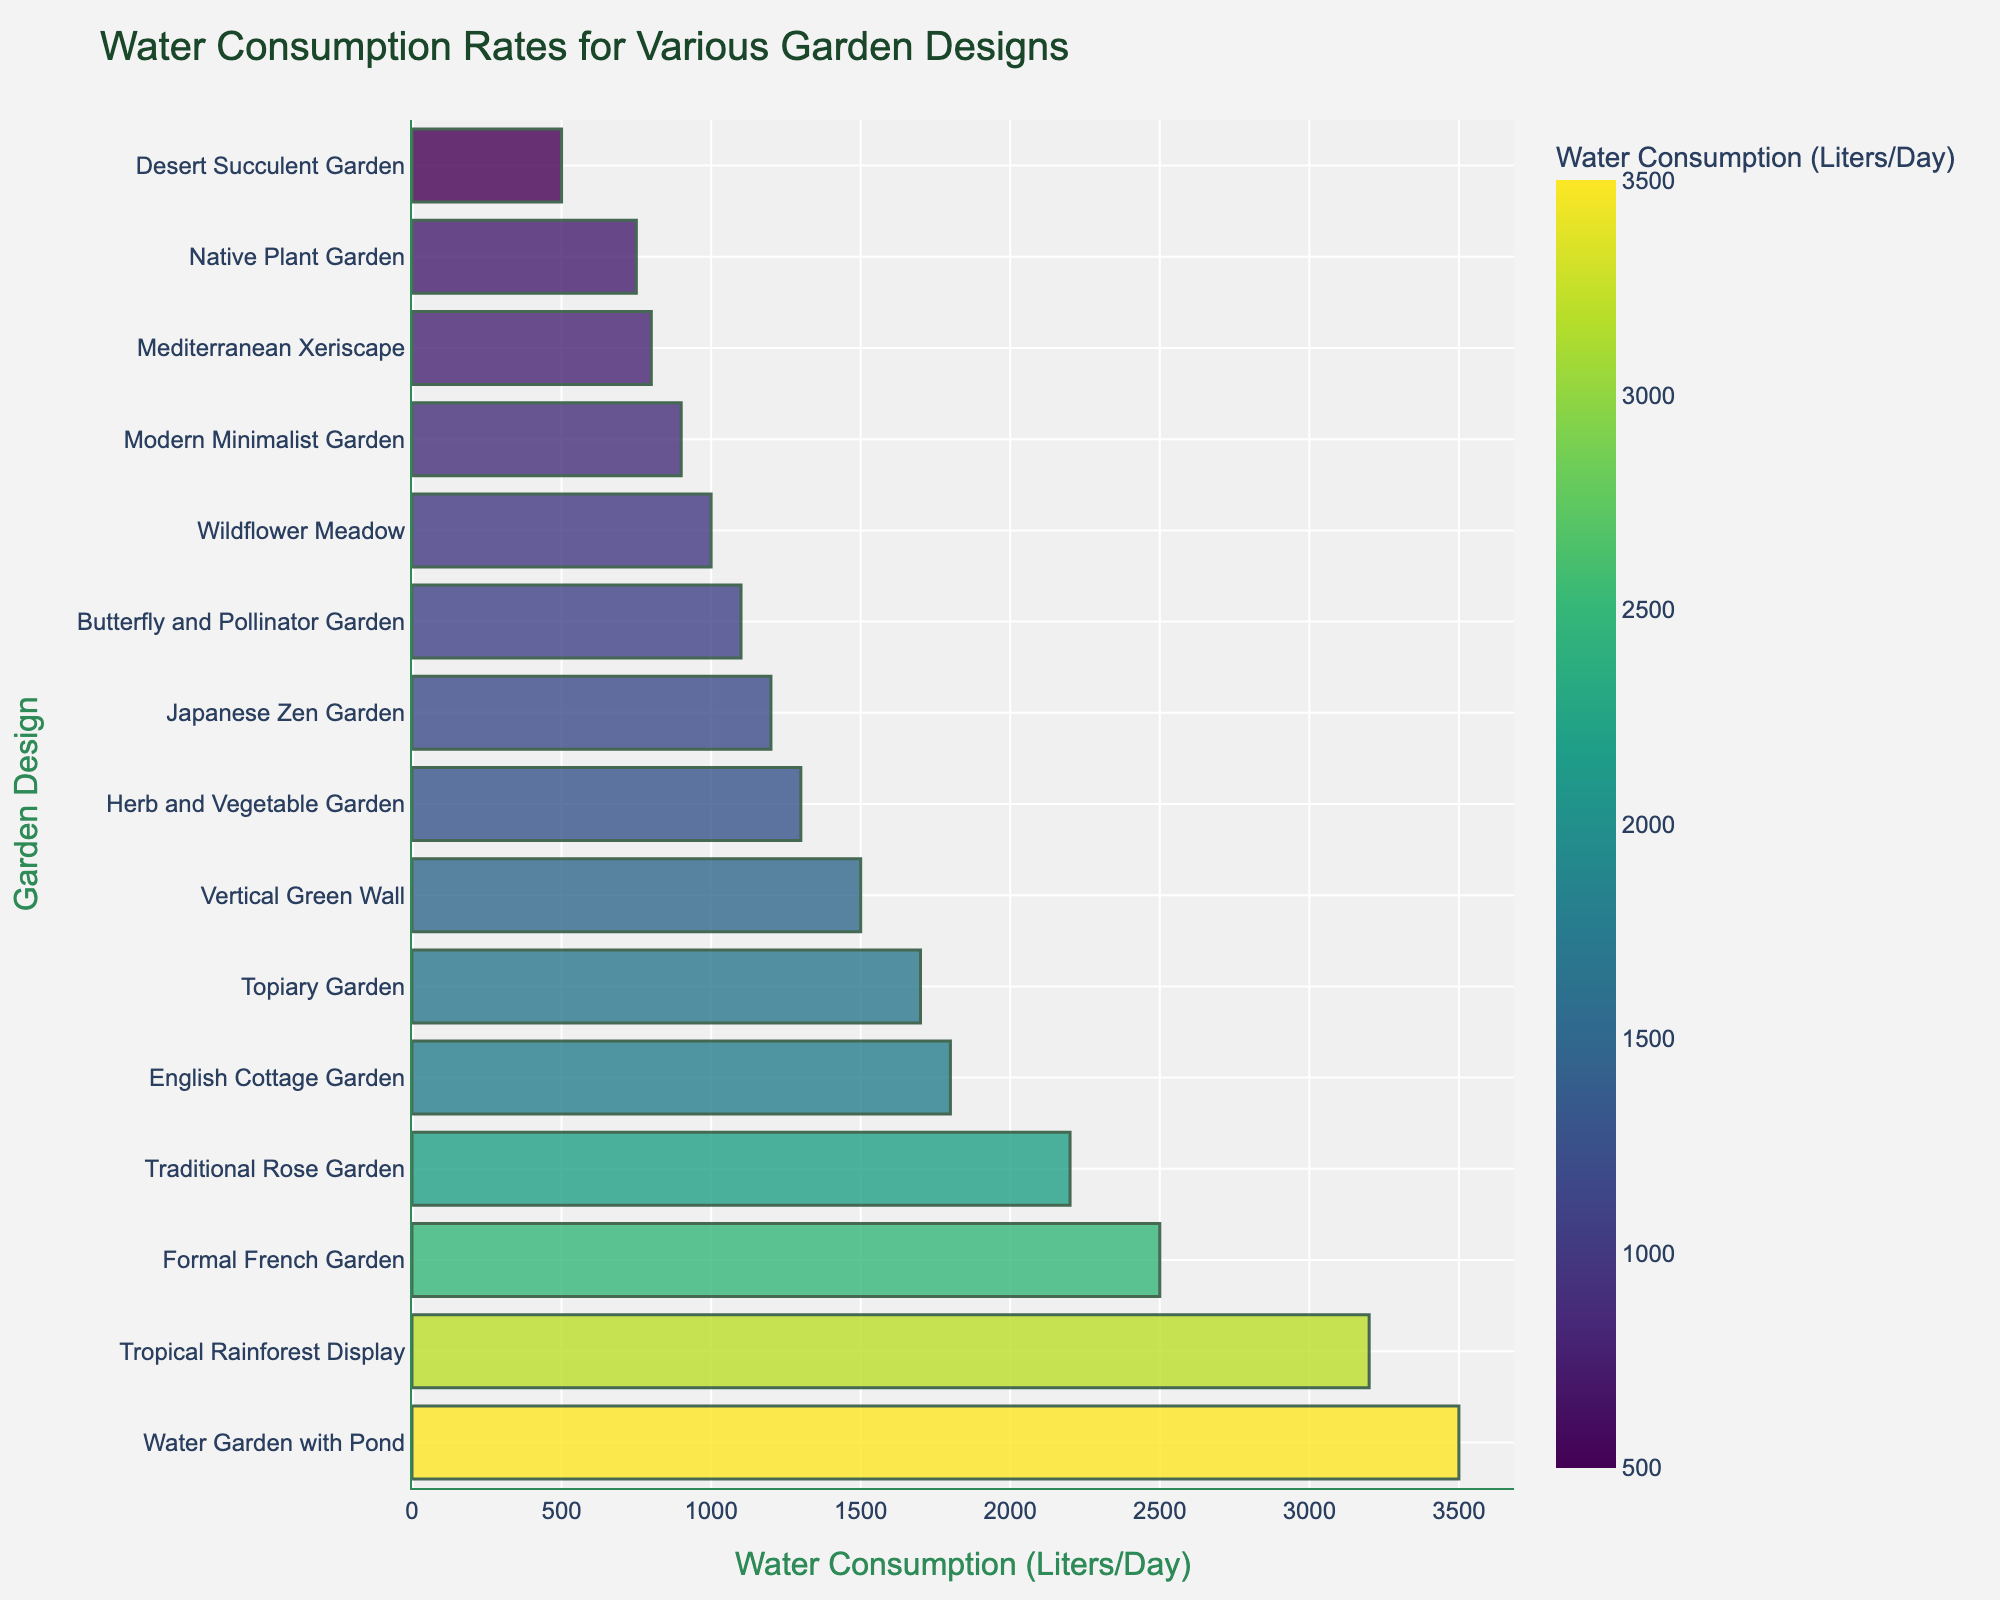Which garden design consumes the most water? The tallest bar on the chart represents the garden design with the highest water consumption rate. This bar corresponds to the "Water Garden with Pond."
Answer: Water Garden with Pond Which garden design consumes the least water? The shortest bar on the chart represents the garden design with the lowest water consumption rate. This bar corresponds to the "Desert Succulent Garden."
Answer: Desert Succulent Garden How much more water does the Water Garden with Pond consume compared to the Desert Succulent Garden? Find the water consumption values for both gardens. The Water Garden with Pond consumes 3500 liters/day, and the Desert Succulent Garden consumes 500 liters/day. Subtract the two values: 3500 - 500.
Answer: 3000 liters/day What is the average water consumption rate among all garden designs? To find the average, sum all the water consumption rates and divide by the number of garden designs. The sum is 2500 + 1800 + 1200 + 800 + 3200 + 500 + 1000 + 900 + 1500 + 2200 + 1300 + 3500 + 750 + 1100 + 1700 = 24050. There are 15 designs, so the average is 24050 / 15.
Answer: 1603.33 liters/day Is the Japanese Zen Garden's water consumption rate more or less than the median water consumption rate of all garden designs? First, arrange the water consumption values in ascending order: 500, 750, 800, 900, 1000, 1100, 1200, 1300, 1500, 1700, 1800, 2200, 2500, 3200, 3500. The middle value (8th position) is 1300 liters/day. The Japanese Zen Garden consumes 1200 liters/day, which is less than the median.
Answer: Less Which has a higher water consumption rate: the Traditional Rose Garden or the Formal French Garden? Locate the bars for both designs on the chart. The Traditional Rose Garden consumes 2200 liters/day, while the Formal French Garden consumes 2500 liters/day.
Answer: Formal French Garden What is the total water consumption of the Modern Minimalist Garden, Herb and Vegetable Garden, and Vertical Green Wall combined? Locate the bars for each garden in the chart. Their water consumption rates are 900, 1300, and 1500 liters/day, respectively. Sum these values: 900 + 1300 + 1500.
Answer: 3700 liters/day Which garden designs consume between 1000 and 2000 liters of water per day? Identify the bars that fall within the 1000 to 2000 liters/day range. These include the Wildflower Meadow (1000), Butterfly and Pollinator Garden (1100), Japanese Zen Garden (1200), Herb and Vegetable Garden (1300), Topiary Garden (1700), and English Cottage Garden (1800).
Answer: Wildflower Meadow, Butterfly and Pollinator Garden, Japanese Zen Garden, Herb and Vegetable Garden, Topiary Garden, English Cottage Garden How does the water consumption of the Vertical Green Wall compare visually to the English Cottage Garden? Compare the lengths of the bars. The Vertical Green Wall's bar is shorter than the English Cottage Garden's bar. The exact values are 1500 liters/day for the Vertical Green Wall and 1800 liters/day for the English Cottage Garden.
Answer: Less 